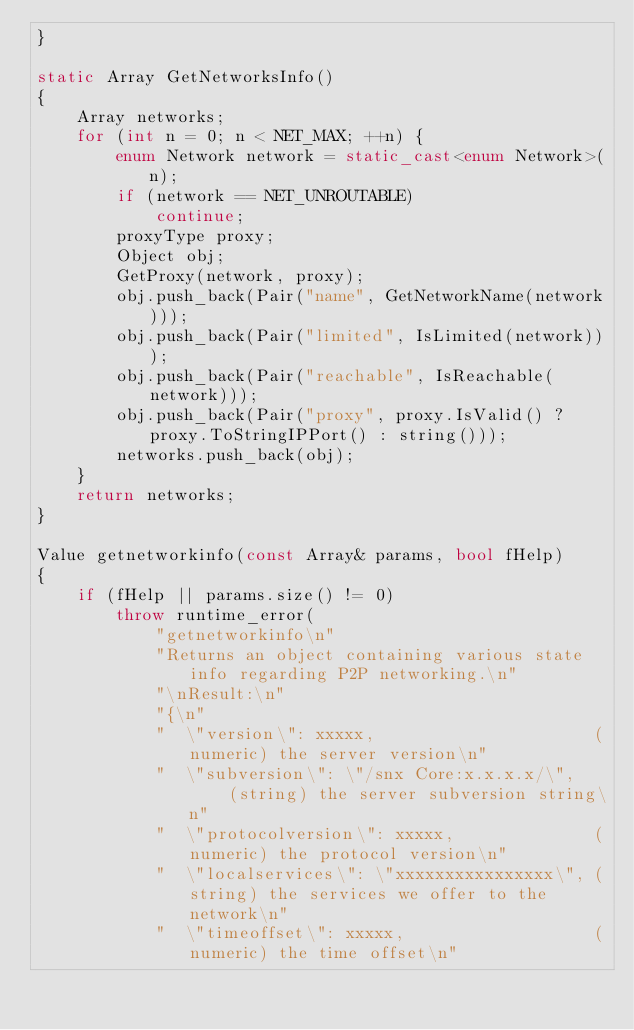<code> <loc_0><loc_0><loc_500><loc_500><_C++_>}

static Array GetNetworksInfo()
{
    Array networks;
    for (int n = 0; n < NET_MAX; ++n) {
        enum Network network = static_cast<enum Network>(n);
        if (network == NET_UNROUTABLE)
            continue;
        proxyType proxy;
        Object obj;
        GetProxy(network, proxy);
        obj.push_back(Pair("name", GetNetworkName(network)));
        obj.push_back(Pair("limited", IsLimited(network)));
        obj.push_back(Pair("reachable", IsReachable(network)));
        obj.push_back(Pair("proxy", proxy.IsValid() ? proxy.ToStringIPPort() : string()));
        networks.push_back(obj);
    }
    return networks;
}

Value getnetworkinfo(const Array& params, bool fHelp)
{
    if (fHelp || params.size() != 0)
        throw runtime_error(
            "getnetworkinfo\n"
            "Returns an object containing various state info regarding P2P networking.\n"
            "\nResult:\n"
            "{\n"
            "  \"version\": xxxxx,                      (numeric) the server version\n"
            "  \"subversion\": \"/snx Core:x.x.x.x/\",     (string) the server subversion string\n"
            "  \"protocolversion\": xxxxx,              (numeric) the protocol version\n"
            "  \"localservices\": \"xxxxxxxxxxxxxxxx\", (string) the services we offer to the network\n"
            "  \"timeoffset\": xxxxx,                   (numeric) the time offset\n"</code> 